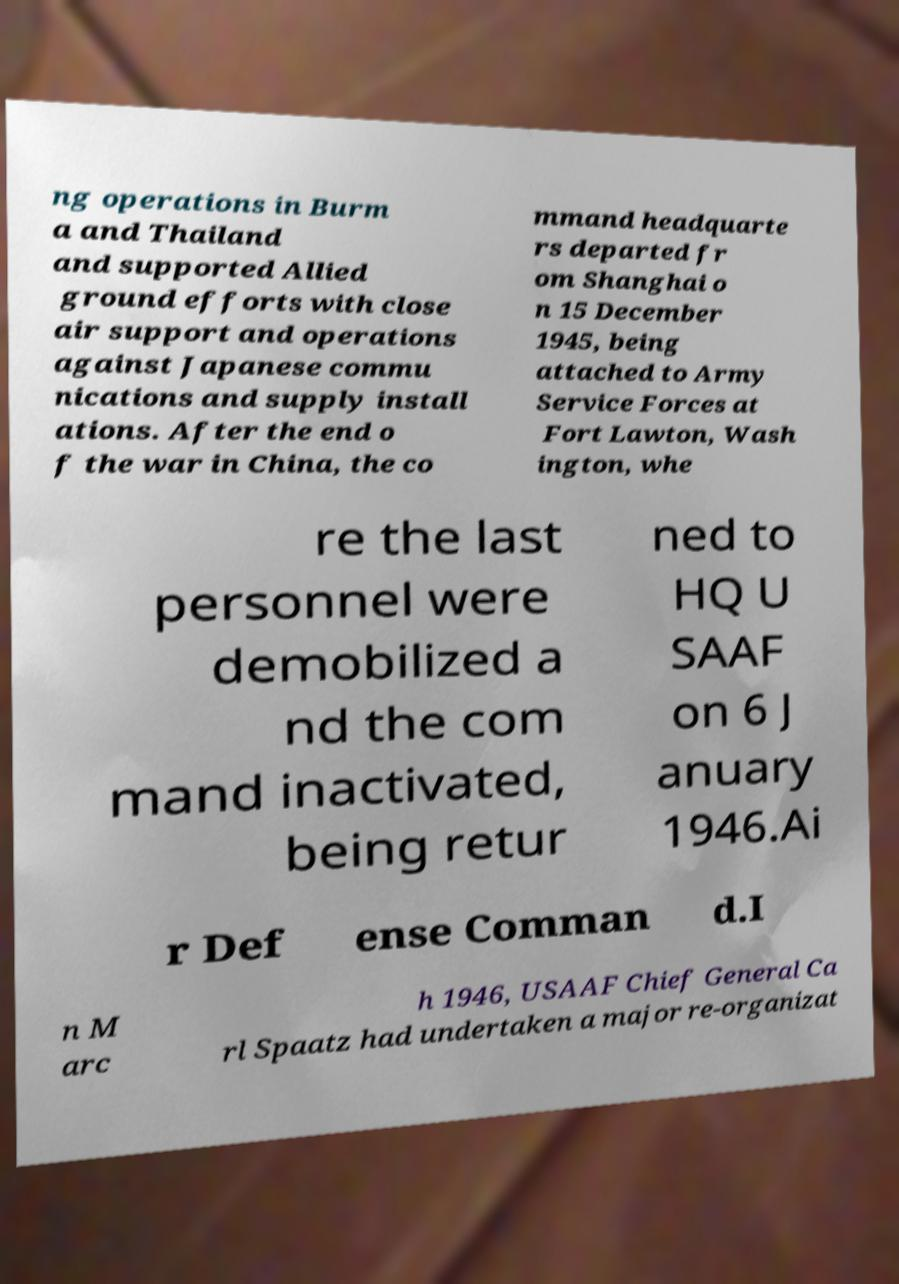I need the written content from this picture converted into text. Can you do that? ng operations in Burm a and Thailand and supported Allied ground efforts with close air support and operations against Japanese commu nications and supply install ations. After the end o f the war in China, the co mmand headquarte rs departed fr om Shanghai o n 15 December 1945, being attached to Army Service Forces at Fort Lawton, Wash ington, whe re the last personnel were demobilized a nd the com mand inactivated, being retur ned to HQ U SAAF on 6 J anuary 1946.Ai r Def ense Comman d.I n M arc h 1946, USAAF Chief General Ca rl Spaatz had undertaken a major re-organizat 